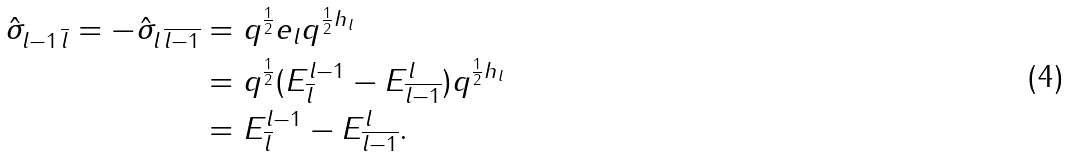Convert formula to latex. <formula><loc_0><loc_0><loc_500><loc_500>\hat { \sigma } _ { l - 1 \, \overline { l } } = - \hat { \sigma } _ { l \, \overline { l - 1 } } & = q ^ { \frac { 1 } { 2 } } e _ { l } q ^ { \frac { 1 } { 2 } h _ { l } } \\ & = q ^ { \frac { 1 } { 2 } } ( E ^ { l - 1 } _ { \overline { l } } - E ^ { l } _ { \overline { l - 1 } } ) q ^ { \frac { 1 } { 2 } h _ { l } } \\ & = E ^ { l - 1 } _ { \overline { l } } - E ^ { l } _ { \overline { l - 1 } } .</formula> 